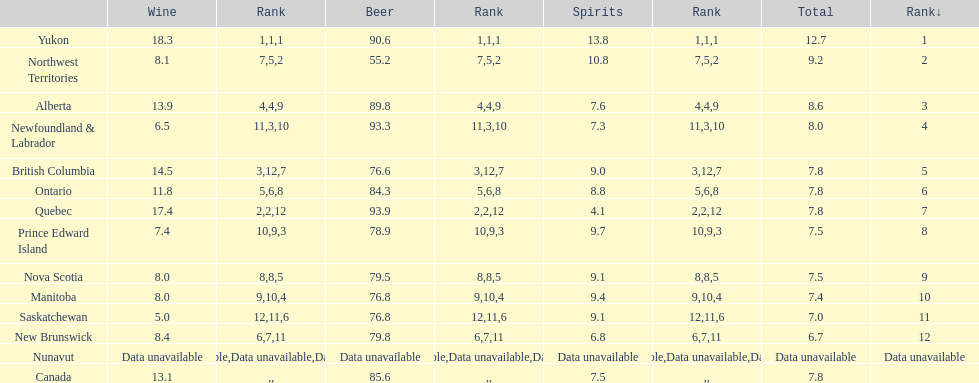In which province was the wine consumption more than 15 liters? Yukon, Quebec. 